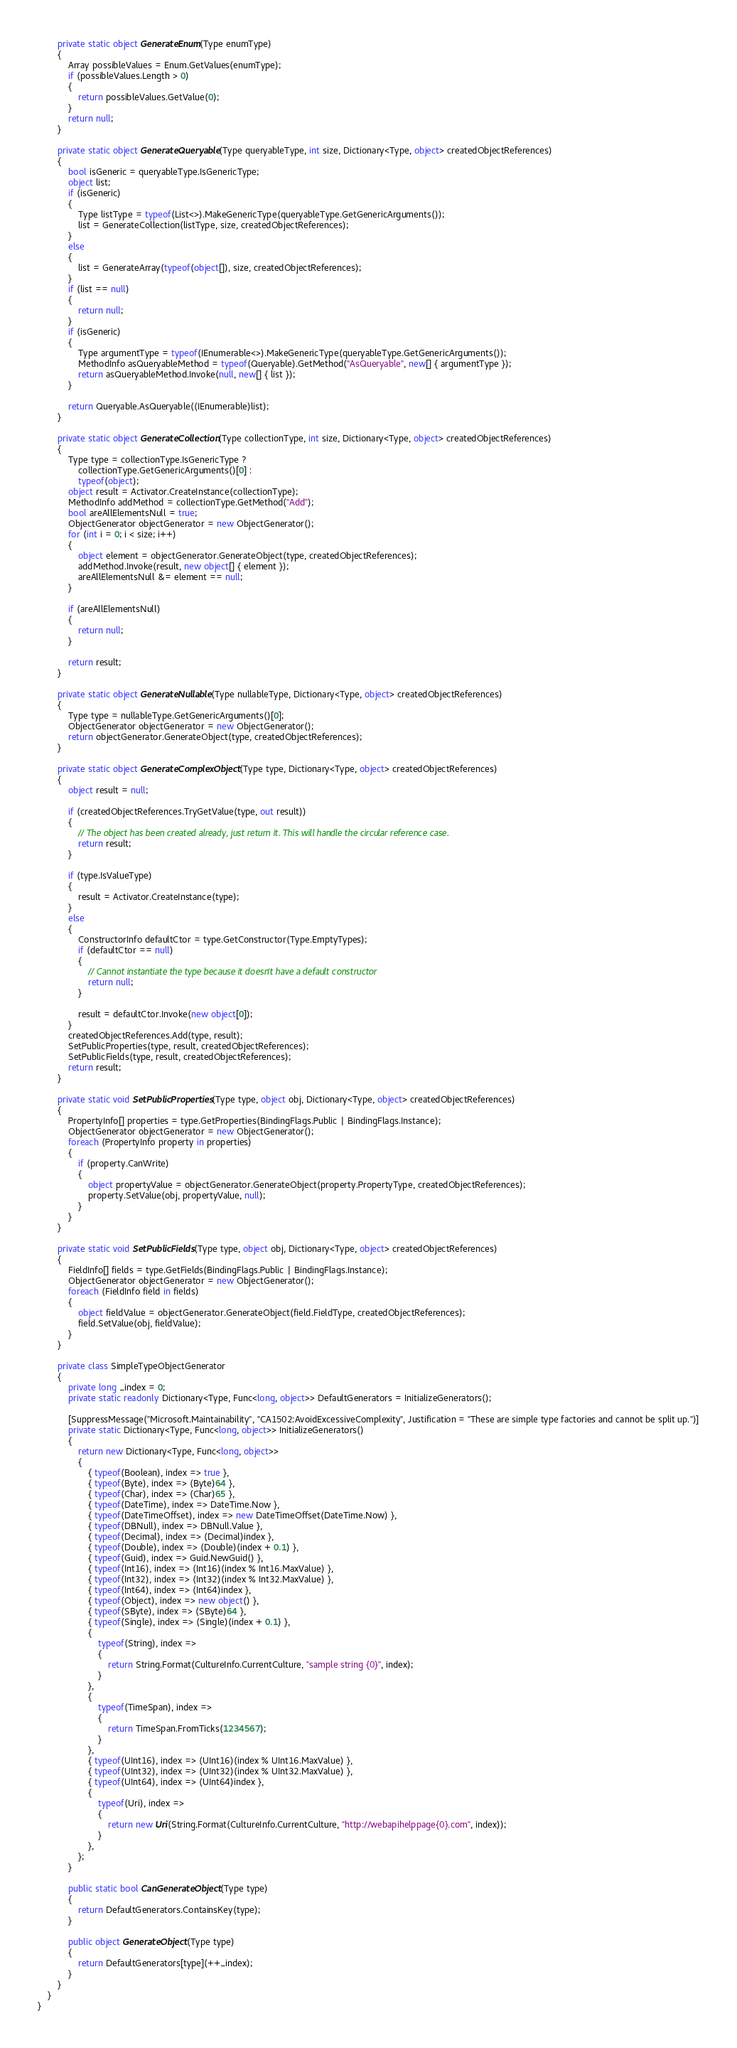<code> <loc_0><loc_0><loc_500><loc_500><_C#_>        private static object GenerateEnum(Type enumType)
        {
            Array possibleValues = Enum.GetValues(enumType);
            if (possibleValues.Length > 0)
            {
                return possibleValues.GetValue(0);
            }
            return null;
        }

        private static object GenerateQueryable(Type queryableType, int size, Dictionary<Type, object> createdObjectReferences)
        {
            bool isGeneric = queryableType.IsGenericType;
            object list;
            if (isGeneric)
            {
                Type listType = typeof(List<>).MakeGenericType(queryableType.GetGenericArguments());
                list = GenerateCollection(listType, size, createdObjectReferences);
            }
            else
            {
                list = GenerateArray(typeof(object[]), size, createdObjectReferences);
            }
            if (list == null)
            {
                return null;
            }
            if (isGeneric)
            {
                Type argumentType = typeof(IEnumerable<>).MakeGenericType(queryableType.GetGenericArguments());
                MethodInfo asQueryableMethod = typeof(Queryable).GetMethod("AsQueryable", new[] { argumentType });
                return asQueryableMethod.Invoke(null, new[] { list });
            }

            return Queryable.AsQueryable((IEnumerable)list);
        }

        private static object GenerateCollection(Type collectionType, int size, Dictionary<Type, object> createdObjectReferences)
        {
            Type type = collectionType.IsGenericType ?
                collectionType.GetGenericArguments()[0] :
                typeof(object);
            object result = Activator.CreateInstance(collectionType);
            MethodInfo addMethod = collectionType.GetMethod("Add");
            bool areAllElementsNull = true;
            ObjectGenerator objectGenerator = new ObjectGenerator();
            for (int i = 0; i < size; i++)
            {
                object element = objectGenerator.GenerateObject(type, createdObjectReferences);
                addMethod.Invoke(result, new object[] { element });
                areAllElementsNull &= element == null;
            }

            if (areAllElementsNull)
            {
                return null;
            }

            return result;
        }

        private static object GenerateNullable(Type nullableType, Dictionary<Type, object> createdObjectReferences)
        {
            Type type = nullableType.GetGenericArguments()[0];
            ObjectGenerator objectGenerator = new ObjectGenerator();
            return objectGenerator.GenerateObject(type, createdObjectReferences);
        }

        private static object GenerateComplexObject(Type type, Dictionary<Type, object> createdObjectReferences)
        {
            object result = null;

            if (createdObjectReferences.TryGetValue(type, out result))
            {
                // The object has been created already, just return it. This will handle the circular reference case.
                return result;
            }

            if (type.IsValueType)
            {
                result = Activator.CreateInstance(type);
            }
            else
            {
                ConstructorInfo defaultCtor = type.GetConstructor(Type.EmptyTypes);
                if (defaultCtor == null)
                {
                    // Cannot instantiate the type because it doesn't have a default constructor
                    return null;
                }

                result = defaultCtor.Invoke(new object[0]);
            }
            createdObjectReferences.Add(type, result);
            SetPublicProperties(type, result, createdObjectReferences);
            SetPublicFields(type, result, createdObjectReferences);
            return result;
        }

        private static void SetPublicProperties(Type type, object obj, Dictionary<Type, object> createdObjectReferences)
        {
            PropertyInfo[] properties = type.GetProperties(BindingFlags.Public | BindingFlags.Instance);
            ObjectGenerator objectGenerator = new ObjectGenerator();
            foreach (PropertyInfo property in properties)
            {
                if (property.CanWrite)
                {
                    object propertyValue = objectGenerator.GenerateObject(property.PropertyType, createdObjectReferences);
                    property.SetValue(obj, propertyValue, null);
                }
            }
        }

        private static void SetPublicFields(Type type, object obj, Dictionary<Type, object> createdObjectReferences)
        {
            FieldInfo[] fields = type.GetFields(BindingFlags.Public | BindingFlags.Instance);
            ObjectGenerator objectGenerator = new ObjectGenerator();
            foreach (FieldInfo field in fields)
            {
                object fieldValue = objectGenerator.GenerateObject(field.FieldType, createdObjectReferences);
                field.SetValue(obj, fieldValue);
            }
        }

        private class SimpleTypeObjectGenerator
        {
            private long _index = 0;
            private static readonly Dictionary<Type, Func<long, object>> DefaultGenerators = InitializeGenerators();

            [SuppressMessage("Microsoft.Maintainability", "CA1502:AvoidExcessiveComplexity", Justification = "These are simple type factories and cannot be split up.")]
            private static Dictionary<Type, Func<long, object>> InitializeGenerators()
            {
                return new Dictionary<Type, Func<long, object>>
                {
                    { typeof(Boolean), index => true },
                    { typeof(Byte), index => (Byte)64 },
                    { typeof(Char), index => (Char)65 },
                    { typeof(DateTime), index => DateTime.Now },
                    { typeof(DateTimeOffset), index => new DateTimeOffset(DateTime.Now) },
                    { typeof(DBNull), index => DBNull.Value },
                    { typeof(Decimal), index => (Decimal)index },
                    { typeof(Double), index => (Double)(index + 0.1) },
                    { typeof(Guid), index => Guid.NewGuid() },
                    { typeof(Int16), index => (Int16)(index % Int16.MaxValue) },
                    { typeof(Int32), index => (Int32)(index % Int32.MaxValue) },
                    { typeof(Int64), index => (Int64)index },
                    { typeof(Object), index => new object() },
                    { typeof(SByte), index => (SByte)64 },
                    { typeof(Single), index => (Single)(index + 0.1) },
                    { 
                        typeof(String), index =>
                        {
                            return String.Format(CultureInfo.CurrentCulture, "sample string {0}", index);
                        }
                    },
                    { 
                        typeof(TimeSpan), index =>
                        {
                            return TimeSpan.FromTicks(1234567);
                        }
                    },
                    { typeof(UInt16), index => (UInt16)(index % UInt16.MaxValue) },
                    { typeof(UInt32), index => (UInt32)(index % UInt32.MaxValue) },
                    { typeof(UInt64), index => (UInt64)index },
                    { 
                        typeof(Uri), index =>
                        {
                            return new Uri(String.Format(CultureInfo.CurrentCulture, "http://webapihelppage{0}.com", index));
                        }
                    },
                };
            }

            public static bool CanGenerateObject(Type type)
            {
                return DefaultGenerators.ContainsKey(type);
            }

            public object GenerateObject(Type type)
            {
                return DefaultGenerators[type](++_index);
            }
        }
    }
}</code> 